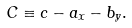<formula> <loc_0><loc_0><loc_500><loc_500>C \equiv c - a _ { x } - b _ { y } .</formula> 